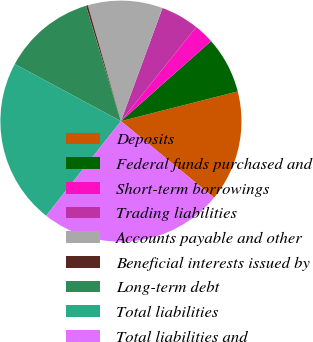Convert chart. <chart><loc_0><loc_0><loc_500><loc_500><pie_chart><fcel>Deposits<fcel>Federal funds purchased and<fcel>Short-term borrowings<fcel>Trading liabilities<fcel>Accounts payable and other<fcel>Beneficial interests issued by<fcel>Long-term debt<fcel>Total liabilities<fcel>Total liabilities and<nl><fcel>14.92%<fcel>7.59%<fcel>2.7%<fcel>5.14%<fcel>10.03%<fcel>0.25%<fcel>12.47%<fcel>22.2%<fcel>24.69%<nl></chart> 